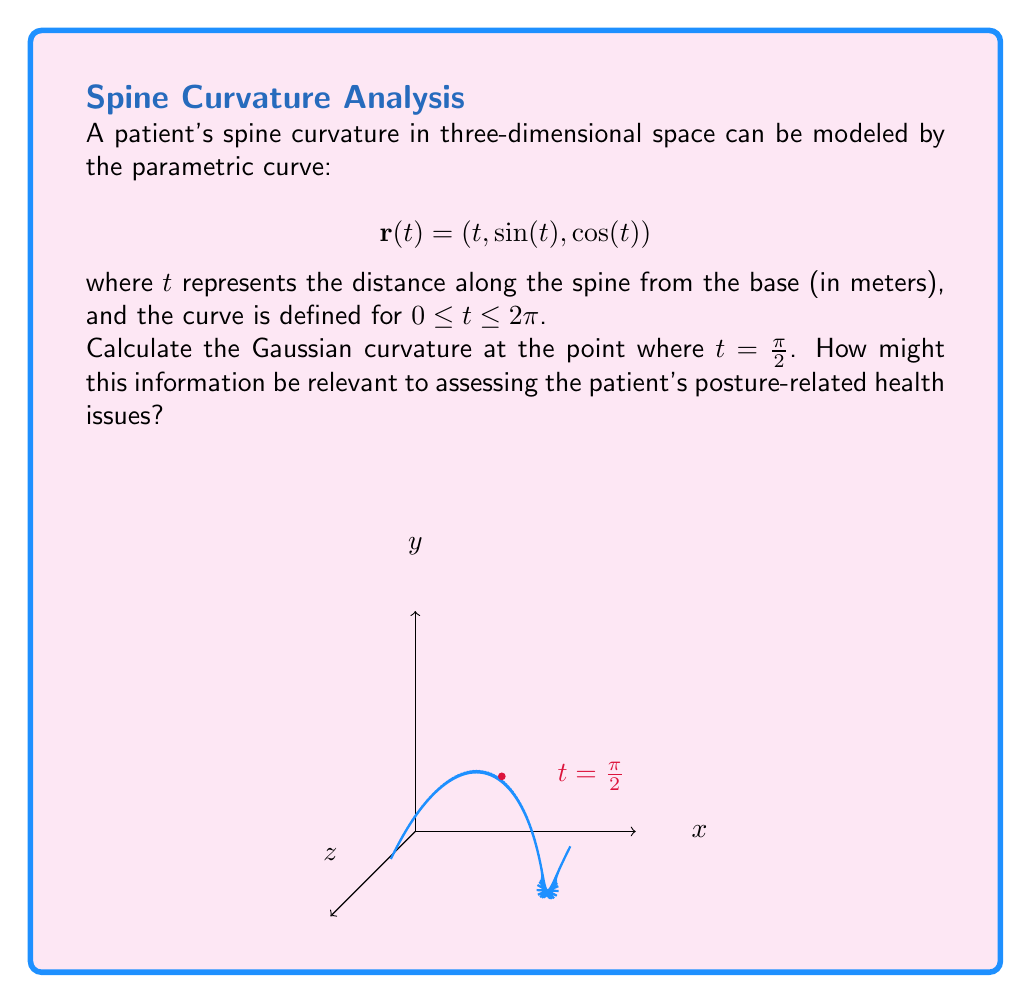Could you help me with this problem? To calculate the Gaussian curvature, we need to follow these steps:

1) First, we need to find the first and second derivatives of $\mathbf{r}(t)$:

   $$\mathbf{r}'(t) = (1, \cos(t), -\sin(t))$$
   $$\mathbf{r}''(t) = (0, -\sin(t), -\cos(t))$$

2) The unit tangent vector $\mathbf{T}(t)$ is given by:

   $$\mathbf{T}(t) = \frac{\mathbf{r}'(t)}{|\mathbf{r}'(t)|} = \frac{(1, \cos(t), -\sin(t))}{\sqrt{1 + \cos^2(t) + \sin^2(t)}} = \frac{(1, \cos(t), -\sin(t))}{\sqrt{2}}$$

3) The normal vector $\mathbf{N}(t)$ is:

   $$\mathbf{N}(t) = \frac{\mathbf{r}'(t) \times \mathbf{r}''(t)}{|\mathbf{r}'(t) \times \mathbf{r}''(t)|} = \frac{(\cos(t), -\sin(t), 1)}{\sqrt{2}}$$

4) The binormal vector $\mathbf{B}(t)$ is:

   $$\mathbf{B}(t) = \mathbf{T}(t) \times \mathbf{N}(t) = \frac{(-\sin(t), -\cos(t), 0)}{\sqrt{2}}$$

5) Now, we can calculate the curvature $\kappa$ and torsion $\tau$:

   $$\kappa = |\mathbf{r}'(t) \times \mathbf{r}''(t)| \cdot |\mathbf{r}'(t)|^{-3} = \frac{1}{\sqrt{2}}$$
   
   $$\tau = \frac{\mathbf{r}'(t) \cdot (\mathbf{r}''(t) \times \mathbf{r}'''(t))}{|\mathbf{r}'(t) \times \mathbf{r}''(t)|^2} = \frac{1}{\sqrt{2}}$$

6) The Gaussian curvature $K$ is given by:

   $$K = \kappa^2 - \tau^2$$

7) Substituting the values at $t = \frac{\pi}{2}$:

   $$K = (\frac{1}{\sqrt{2}})^2 - (\frac{1}{\sqrt{2}})^2 = \frac{1}{2} - \frac{1}{2} = 0$$

This result indicates that the surface at this point is flat in the Gaussian sense, which means it can be locally unfolded onto a plane without distortion. For a pharmacist, this information is crucial in assessing the patient's spinal health. A Gaussian curvature of zero at this point suggests that the spine has a natural, healthy curvature at this location, which is important for proper posture and spinal function. Deviations from this value at key points along the spine could indicate potential posture-related health issues that may require further investigation or treatment.
Answer: $K = 0$ 